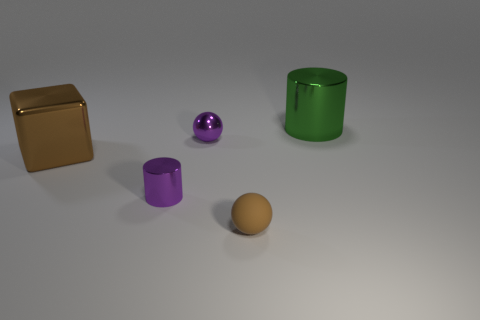Add 2 brown cubes. How many objects exist? 7 Subtract all balls. How many objects are left? 3 Add 3 rubber blocks. How many rubber blocks exist? 3 Subtract 0 blue cylinders. How many objects are left? 5 Subtract all large cylinders. Subtract all rubber spheres. How many objects are left? 3 Add 5 metallic blocks. How many metallic blocks are left? 6 